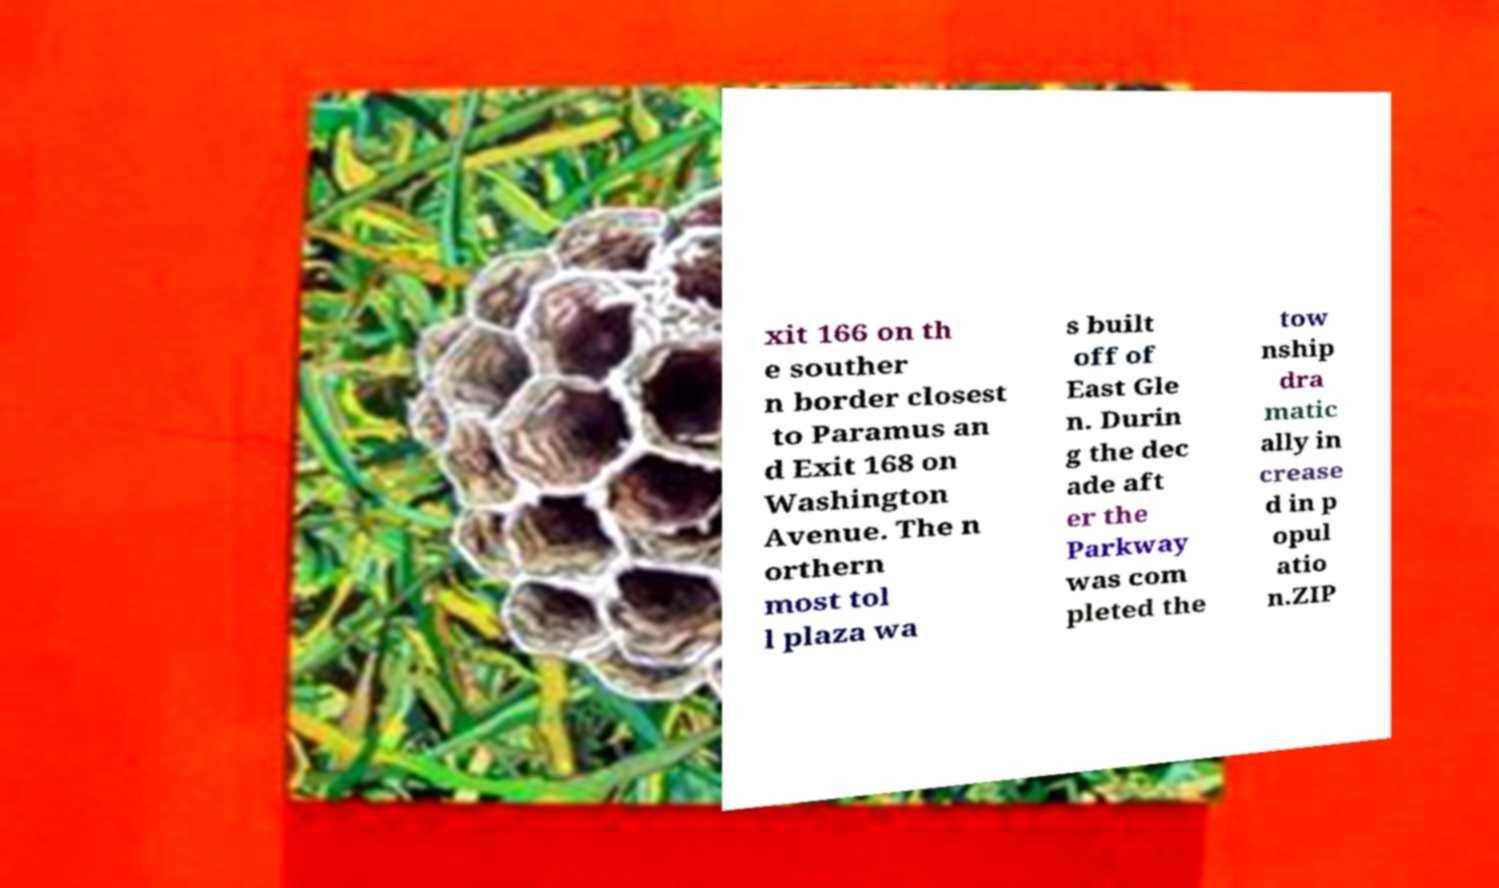Please read and relay the text visible in this image. What does it say? xit 166 on th e souther n border closest to Paramus an d Exit 168 on Washington Avenue. The n orthern most tol l plaza wa s built off of East Gle n. Durin g the dec ade aft er the Parkway was com pleted the tow nship dra matic ally in crease d in p opul atio n.ZIP 